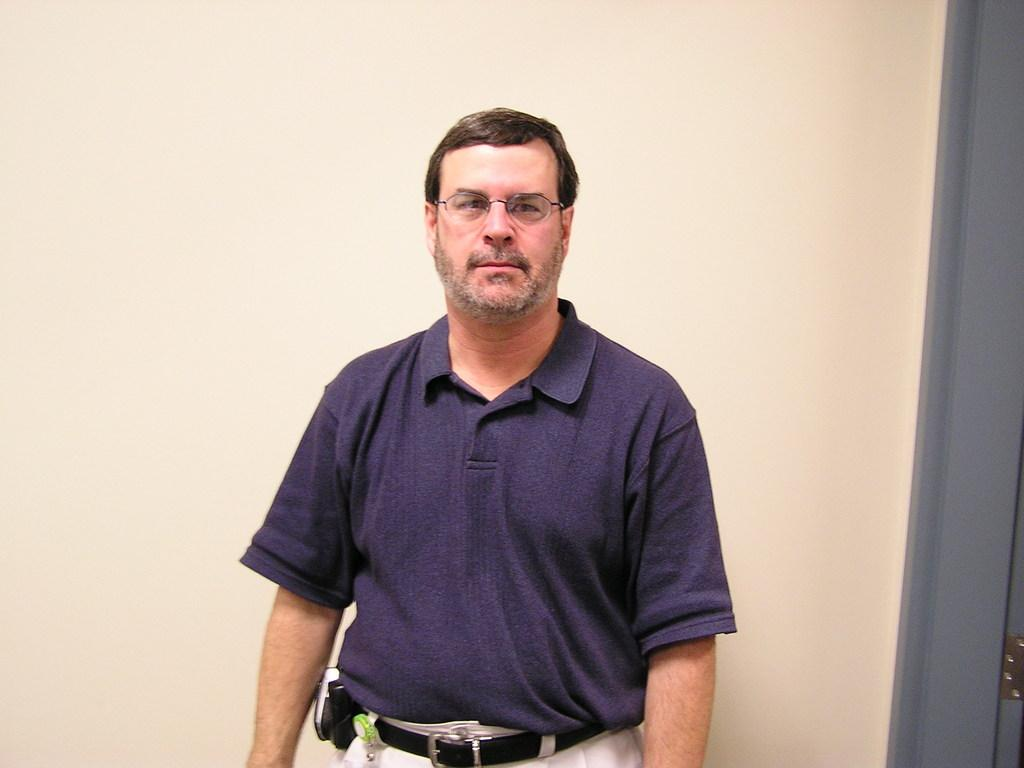What is the main subject of the image? There is a man in the image. What type of clothing is the man wearing on his upper body? The man is wearing a t-shirt. What type of clothing is the man wearing on his lower body? The man is wearing trousers. What accessory is the man wearing around his waist? The man is wearing a belt. What color is the belt that the man is wearing? The belt is cream in color. What type of beetle can be seen crawling on the man's t-shirt in the image? There is no beetle present on the man's t-shirt in the image. What type of cart is the man pushing in the image? There is no cart present in the image. 